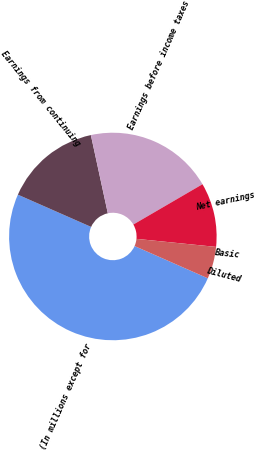Convert chart. <chart><loc_0><loc_0><loc_500><loc_500><pie_chart><fcel>(In millions except for<fcel>Earnings from continuing<fcel>Earnings before income taxes<fcel>Net earnings<fcel>Basic<fcel>Diluted<nl><fcel>50.0%<fcel>15.0%<fcel>20.0%<fcel>10.0%<fcel>0.0%<fcel>5.0%<nl></chart> 